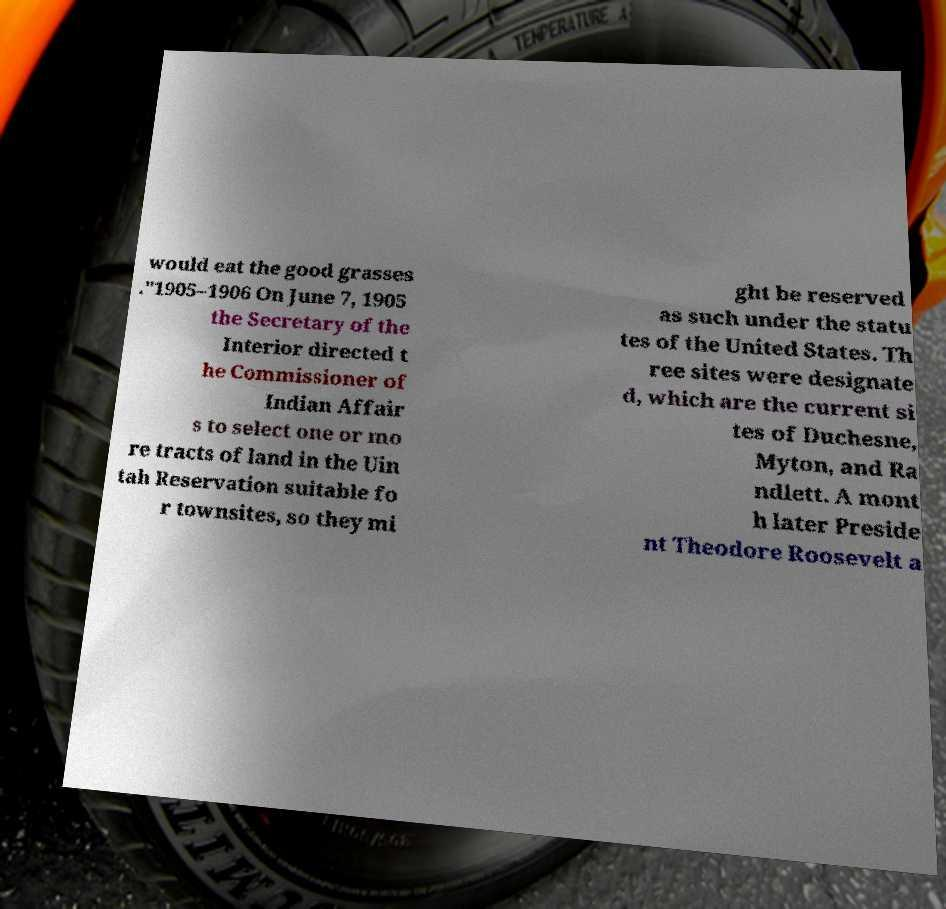Can you read and provide the text displayed in the image?This photo seems to have some interesting text. Can you extract and type it out for me? would eat the good grasses ."1905–1906 On June 7, 1905 the Secretary of the Interior directed t he Commissioner of Indian Affair s to select one or mo re tracts of land in the Uin tah Reservation suitable fo r townsites, so they mi ght be reserved as such under the statu tes of the United States. Th ree sites were designate d, which are the current si tes of Duchesne, Myton, and Ra ndlett. A mont h later Preside nt Theodore Roosevelt a 